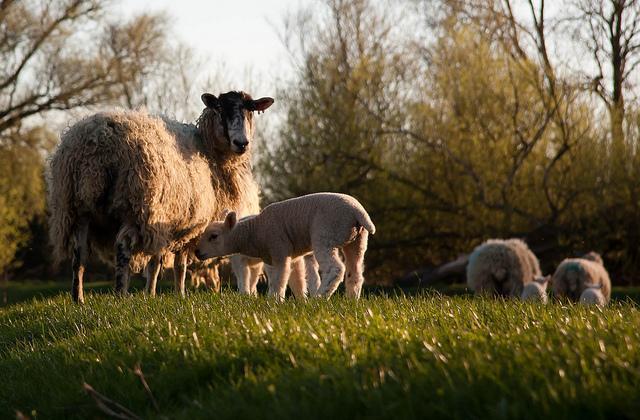How many lambs in this picture?
Give a very brief answer. 4. How many animals are in this photo?
Give a very brief answer. 6. How many sheep are in the picture?
Give a very brief answer. 4. 